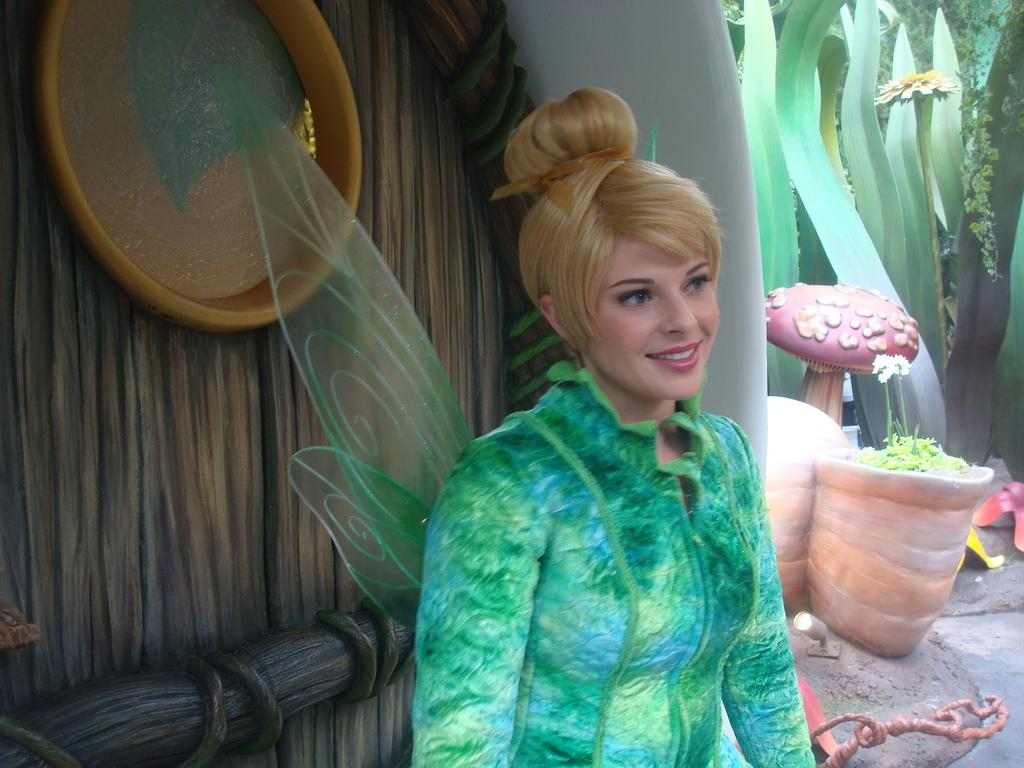What type of structure can be seen in the image? There is a wall in the image. What type of window treatment is present in the image? There are curtains in the image. What type of vegetation is visible in the image? There are plants in the image. What type of floral element is present in the image? There is a flower in the image. Who is present in the image? There is a woman in the image. What color is the dress the woman is wearing? The woman is wearing a green dress. What role does the actor play in the image? There is no actor present in the image; it features a woman wearing a green dress. What type of selection process is depicted in the image? There is no selection process depicted in the image; it features a woman, plants, a flower, and curtains. 